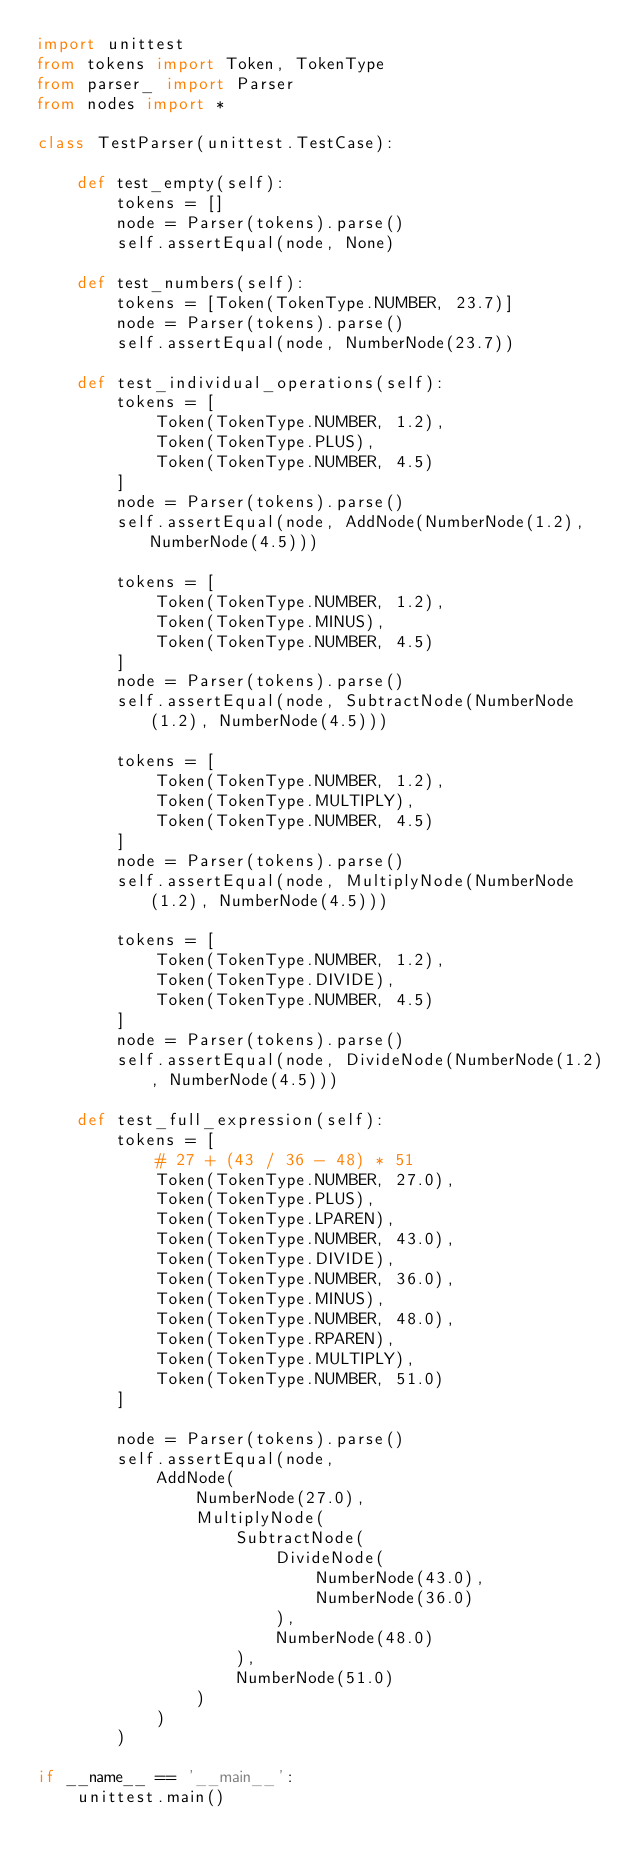Convert code to text. <code><loc_0><loc_0><loc_500><loc_500><_Python_>import unittest
from tokens import Token, TokenType
from parser_ import Parser
from nodes import *

class TestParser(unittest.TestCase):

    def test_empty(self):
        tokens = []
        node = Parser(tokens).parse()
        self.assertEqual(node, None)

    def test_numbers(self):
        tokens = [Token(TokenType.NUMBER, 23.7)]
        node = Parser(tokens).parse()
        self.assertEqual(node, NumberNode(23.7)) 

    def test_individual_operations(self):
        tokens = [
            Token(TokenType.NUMBER, 1.2),
            Token(TokenType.PLUS),
            Token(TokenType.NUMBER, 4.5)
        ]
        node = Parser(tokens).parse()
        self.assertEqual(node, AddNode(NumberNode(1.2), NumberNode(4.5))) 

        tokens = [
            Token(TokenType.NUMBER, 1.2),
            Token(TokenType.MINUS),
            Token(TokenType.NUMBER, 4.5)
        ]
        node = Parser(tokens).parse()
        self.assertEqual(node, SubtractNode(NumberNode(1.2), NumberNode(4.5))) 

        tokens = [
            Token(TokenType.NUMBER, 1.2),
            Token(TokenType.MULTIPLY),
            Token(TokenType.NUMBER, 4.5)
        ]
        node = Parser(tokens).parse()
        self.assertEqual(node, MultiplyNode(NumberNode(1.2), NumberNode(4.5))) 

        tokens = [
            Token(TokenType.NUMBER, 1.2),
            Token(TokenType.DIVIDE),
            Token(TokenType.NUMBER, 4.5)
        ]
        node = Parser(tokens).parse()
        self.assertEqual(node, DivideNode(NumberNode(1.2), NumberNode(4.5))) 

    def test_full_expression(self):
        tokens = [
            # 27 + (43 / 36 - 48) * 51
            Token(TokenType.NUMBER, 27.0),
            Token(TokenType.PLUS),
            Token(TokenType.LPAREN),
            Token(TokenType.NUMBER, 43.0),
            Token(TokenType.DIVIDE),
            Token(TokenType.NUMBER, 36.0),
            Token(TokenType.MINUS),
            Token(TokenType.NUMBER, 48.0),
            Token(TokenType.RPAREN),
            Token(TokenType.MULTIPLY),
            Token(TokenType.NUMBER, 51.0)
        ]

        node = Parser(tokens).parse()
        self.assertEqual(node, 
            AddNode(
                NumberNode(27.0), 
                MultiplyNode(
                    SubtractNode(
                        DivideNode(
                            NumberNode(43.0), 
                            NumberNode(36.0)
                        ),
                        NumberNode(48.0)
                    ), 
                    NumberNode(51.0)
                )
            )
        )

if __name__ == '__main__':
    unittest.main()</code> 